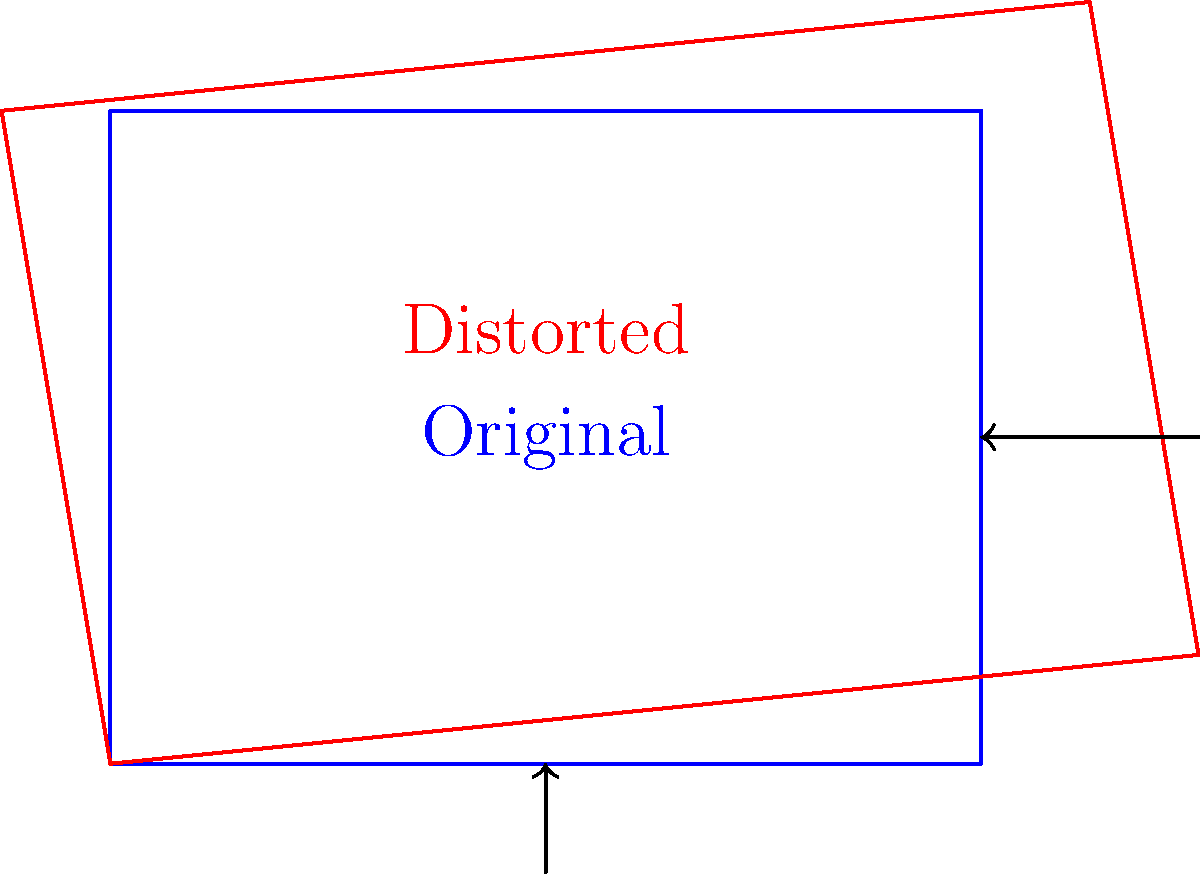As a camera manufacturer, you're developing a lens distortion correction algorithm. Given that the original rectangular image has been distorted as shown in the diagram, which affine transformation matrix would best approximate the correction needed to restore the image to its original shape?

A) $\begin{bmatrix} 0.9 & -0.1 & 0.2 \\ 0.1 & 1.1 & -0.1 \\ 0 & 0 & 1 \end{bmatrix}$

B) $\begin{bmatrix} 1.1 & 0.1 & -0.2 \\ -0.1 & 0.9 & 0.1 \\ 0 & 0 & 1 \end{bmatrix}$

C) $\begin{bmatrix} 0.8 & 0 & 0.5 \\ 0 & 1 & 0 \\ 0 & 0 & 1 \end{bmatrix}$

D) $\begin{bmatrix} 1 & 0 & 0 \\ 0 & 1 & 0 \\ 0.1 & -0.1 & 1 \end{bmatrix}$ To determine the best affine transformation matrix for correcting the lens distortion, we need to analyze the distortion pattern:

1. The image appears to be stretched horizontally, especially on the left side.
2. There's a slight vertical compression.
3. The top-left and bottom-right corners are pulled outwards.

Let's examine each matrix:

A) $\begin{bmatrix} 0.9 & -0.1 & 0.2 \\ 0.1 & 1.1 & -0.1 \\ 0 & 0 & 1 \end{bmatrix}$
This matrix would shrink horizontally (0.9), stretch vertically (1.1), and apply a slight shear, which doesn't match our distortion.

B) $\begin{bmatrix} 1.1 & 0.1 & -0.2 \\ -0.1 & 0.9 & 0.1 \\ 0 & 0 & 1 \end{bmatrix}$
This matrix would stretch horizontally (1.1), compress vertically (0.9), and apply a slight shear. This closely matches the observed distortion.

C) $\begin{bmatrix} 0.8 & 0 & 0.5 \\ 0 & 1 & 0 \\ 0 & 0 & 1 \end{bmatrix}$
This matrix would only compress horizontally and translate, which doesn't address the vertical distortion.

D) $\begin{bmatrix} 1 & 0 & 0 \\ 0 & 1 & 0 \\ 0.1 & -0.1 & 1 \end{bmatrix}$
This matrix represents a perspective transformation, which doesn't match the observed distortion pattern.

Matrix B best approximates the correction needed, as it addresses both the horizontal stretch and vertical compression while also introducing a slight shear that could help correct the corner distortions.
Answer: B 